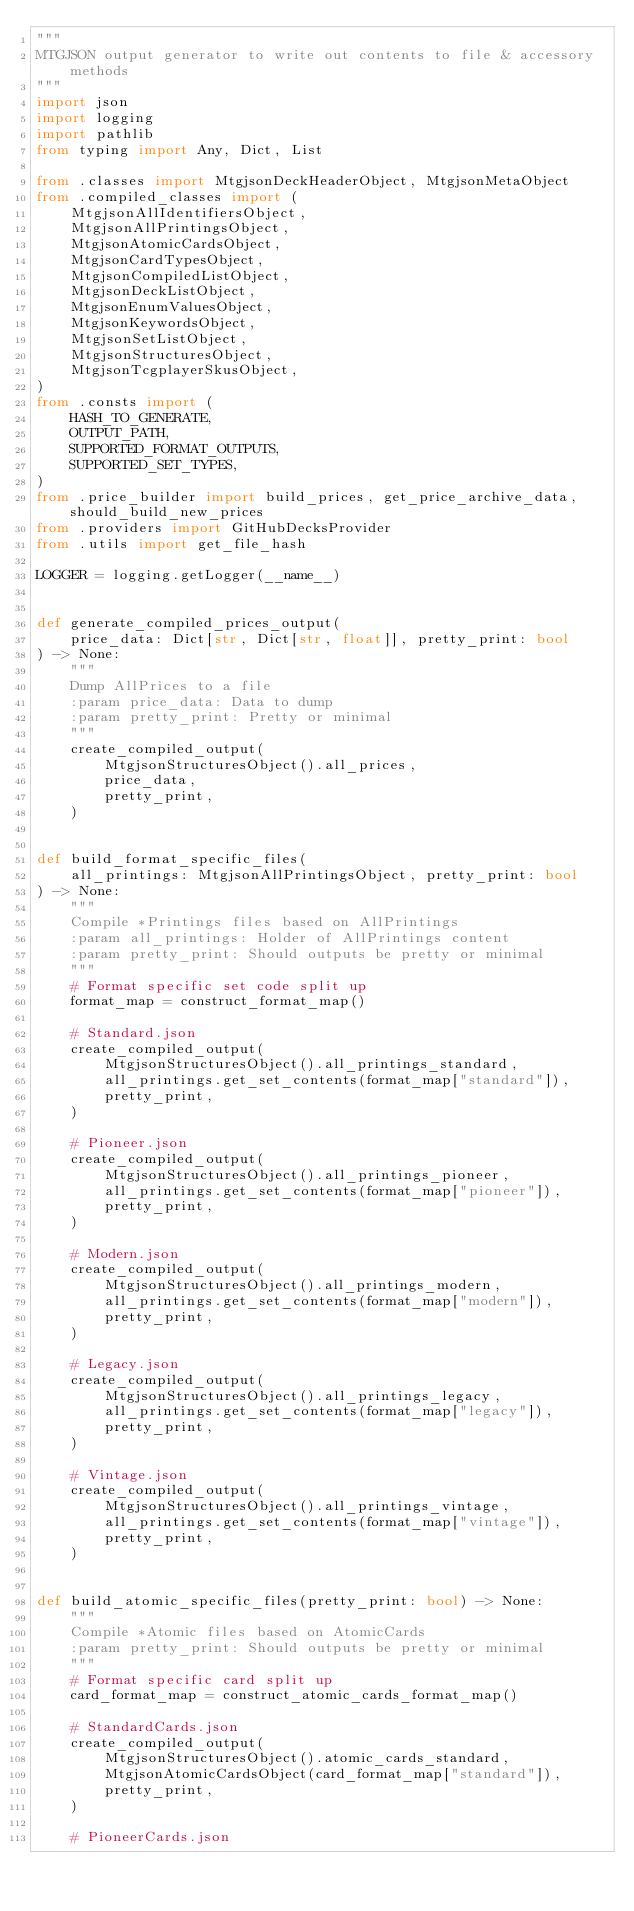<code> <loc_0><loc_0><loc_500><loc_500><_Python_>"""
MTGJSON output generator to write out contents to file & accessory methods
"""
import json
import logging
import pathlib
from typing import Any, Dict, List

from .classes import MtgjsonDeckHeaderObject, MtgjsonMetaObject
from .compiled_classes import (
    MtgjsonAllIdentifiersObject,
    MtgjsonAllPrintingsObject,
    MtgjsonAtomicCardsObject,
    MtgjsonCardTypesObject,
    MtgjsonCompiledListObject,
    MtgjsonDeckListObject,
    MtgjsonEnumValuesObject,
    MtgjsonKeywordsObject,
    MtgjsonSetListObject,
    MtgjsonStructuresObject,
    MtgjsonTcgplayerSkusObject,
)
from .consts import (
    HASH_TO_GENERATE,
    OUTPUT_PATH,
    SUPPORTED_FORMAT_OUTPUTS,
    SUPPORTED_SET_TYPES,
)
from .price_builder import build_prices, get_price_archive_data, should_build_new_prices
from .providers import GitHubDecksProvider
from .utils import get_file_hash

LOGGER = logging.getLogger(__name__)


def generate_compiled_prices_output(
    price_data: Dict[str, Dict[str, float]], pretty_print: bool
) -> None:
    """
    Dump AllPrices to a file
    :param price_data: Data to dump
    :param pretty_print: Pretty or minimal
    """
    create_compiled_output(
        MtgjsonStructuresObject().all_prices,
        price_data,
        pretty_print,
    )


def build_format_specific_files(
    all_printings: MtgjsonAllPrintingsObject, pretty_print: bool
) -> None:
    """
    Compile *Printings files based on AllPrintings
    :param all_printings: Holder of AllPrintings content
    :param pretty_print: Should outputs be pretty or minimal
    """
    # Format specific set code split up
    format_map = construct_format_map()

    # Standard.json
    create_compiled_output(
        MtgjsonStructuresObject().all_printings_standard,
        all_printings.get_set_contents(format_map["standard"]),
        pretty_print,
    )

    # Pioneer.json
    create_compiled_output(
        MtgjsonStructuresObject().all_printings_pioneer,
        all_printings.get_set_contents(format_map["pioneer"]),
        pretty_print,
    )

    # Modern.json
    create_compiled_output(
        MtgjsonStructuresObject().all_printings_modern,
        all_printings.get_set_contents(format_map["modern"]),
        pretty_print,
    )

    # Legacy.json
    create_compiled_output(
        MtgjsonStructuresObject().all_printings_legacy,
        all_printings.get_set_contents(format_map["legacy"]),
        pretty_print,
    )

    # Vintage.json
    create_compiled_output(
        MtgjsonStructuresObject().all_printings_vintage,
        all_printings.get_set_contents(format_map["vintage"]),
        pretty_print,
    )


def build_atomic_specific_files(pretty_print: bool) -> None:
    """
    Compile *Atomic files based on AtomicCards
    :param pretty_print: Should outputs be pretty or minimal
    """
    # Format specific card split up
    card_format_map = construct_atomic_cards_format_map()

    # StandardCards.json
    create_compiled_output(
        MtgjsonStructuresObject().atomic_cards_standard,
        MtgjsonAtomicCardsObject(card_format_map["standard"]),
        pretty_print,
    )

    # PioneerCards.json</code> 